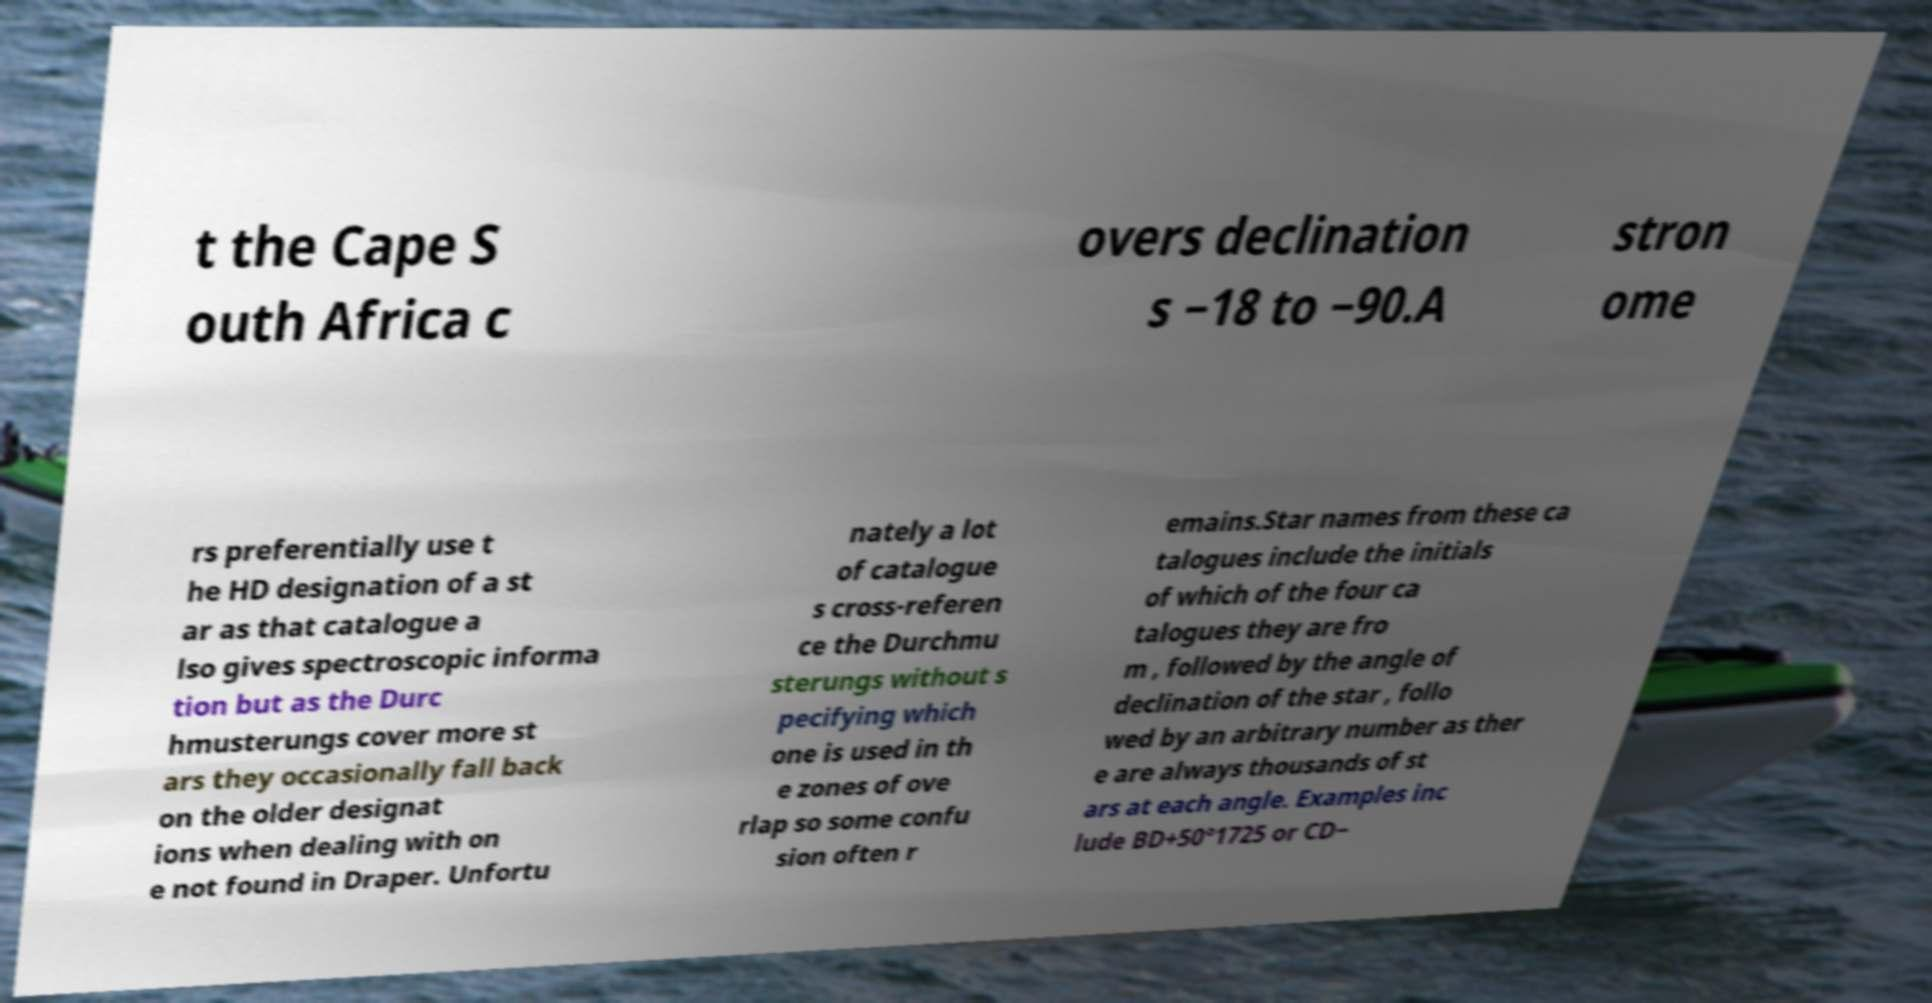There's text embedded in this image that I need extracted. Can you transcribe it verbatim? t the Cape S outh Africa c overs declination s −18 to −90.A stron ome rs preferentially use t he HD designation of a st ar as that catalogue a lso gives spectroscopic informa tion but as the Durc hmusterungs cover more st ars they occasionally fall back on the older designat ions when dealing with on e not found in Draper. Unfortu nately a lot of catalogue s cross-referen ce the Durchmu sterungs without s pecifying which one is used in th e zones of ove rlap so some confu sion often r emains.Star names from these ca talogues include the initials of which of the four ca talogues they are fro m , followed by the angle of declination of the star , follo wed by an arbitrary number as ther e are always thousands of st ars at each angle. Examples inc lude BD+50°1725 or CD− 